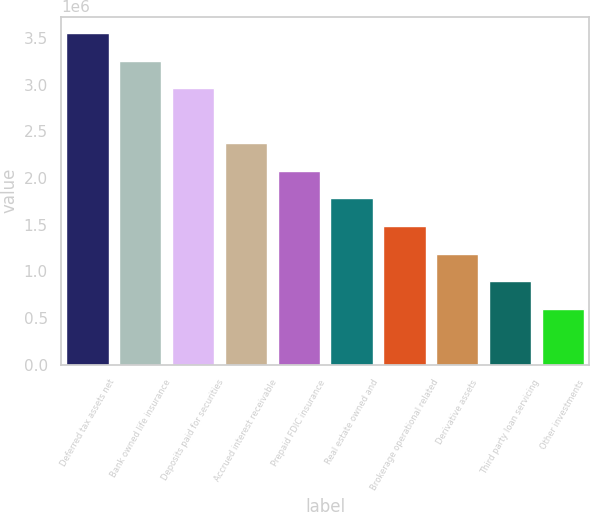Convert chart to OTSL. <chart><loc_0><loc_0><loc_500><loc_500><bar_chart><fcel>Deferred tax assets net<fcel>Bank owned life insurance<fcel>Deposits paid for securities<fcel>Accrued interest receivable<fcel>Prepaid FDIC insurance<fcel>Real estate owned and<fcel>Brokerage operational related<fcel>Derivative assets<fcel>Third party loan servicing<fcel>Other investments<nl><fcel>3.55046e+06<fcel>3.25557e+06<fcel>2.96067e+06<fcel>2.37088e+06<fcel>2.07598e+06<fcel>1.78109e+06<fcel>1.48619e+06<fcel>1.1913e+06<fcel>896401<fcel>601505<nl></chart> 